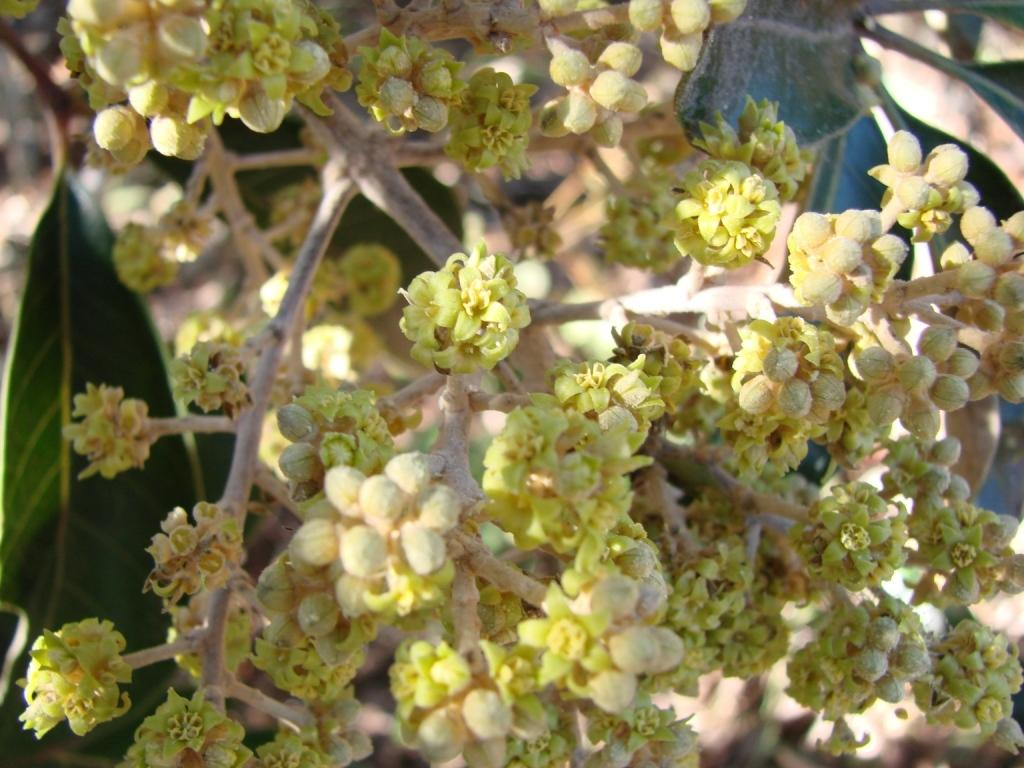What is the main subject of the image? The main subject of the image is many flowers. Can you describe the leaf in the image? There is a leaf on the left side of the image. How many houses can be seen in the image? There are no houses present in the image; it features many flowers and a leaf. What type of can is visible in the image? There is no can present in the image. 